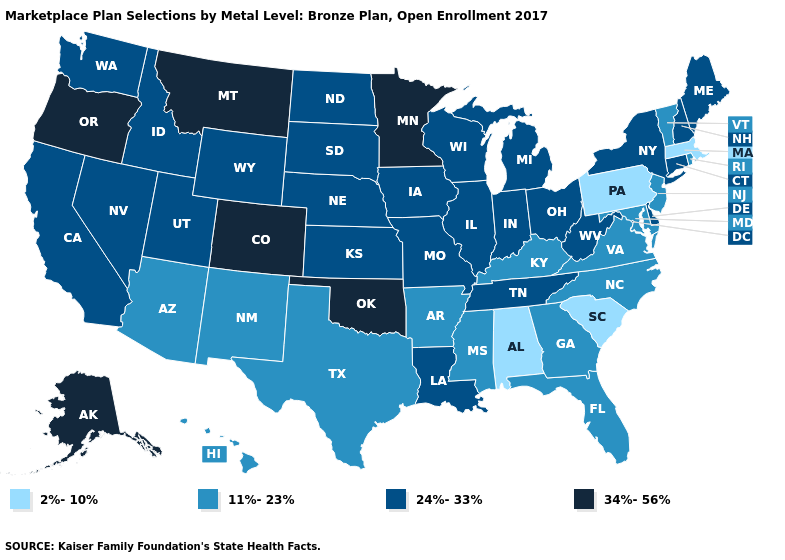Name the states that have a value in the range 24%-33%?
Quick response, please. California, Connecticut, Delaware, Idaho, Illinois, Indiana, Iowa, Kansas, Louisiana, Maine, Michigan, Missouri, Nebraska, Nevada, New Hampshire, New York, North Dakota, Ohio, South Dakota, Tennessee, Utah, Washington, West Virginia, Wisconsin, Wyoming. Name the states that have a value in the range 11%-23%?
Quick response, please. Arizona, Arkansas, Florida, Georgia, Hawaii, Kentucky, Maryland, Mississippi, New Jersey, New Mexico, North Carolina, Rhode Island, Texas, Vermont, Virginia. What is the highest value in states that border Idaho?
Give a very brief answer. 34%-56%. What is the highest value in the USA?
Concise answer only. 34%-56%. Name the states that have a value in the range 11%-23%?
Concise answer only. Arizona, Arkansas, Florida, Georgia, Hawaii, Kentucky, Maryland, Mississippi, New Jersey, New Mexico, North Carolina, Rhode Island, Texas, Vermont, Virginia. What is the highest value in the USA?
Concise answer only. 34%-56%. Does Arkansas have the lowest value in the USA?
Give a very brief answer. No. What is the lowest value in the MidWest?
Give a very brief answer. 24%-33%. Name the states that have a value in the range 11%-23%?
Short answer required. Arizona, Arkansas, Florida, Georgia, Hawaii, Kentucky, Maryland, Mississippi, New Jersey, New Mexico, North Carolina, Rhode Island, Texas, Vermont, Virginia. Name the states that have a value in the range 24%-33%?
Short answer required. California, Connecticut, Delaware, Idaho, Illinois, Indiana, Iowa, Kansas, Louisiana, Maine, Michigan, Missouri, Nebraska, Nevada, New Hampshire, New York, North Dakota, Ohio, South Dakota, Tennessee, Utah, Washington, West Virginia, Wisconsin, Wyoming. Does Vermont have a lower value than North Carolina?
Quick response, please. No. Does South Carolina have the lowest value in the USA?
Quick response, please. Yes. What is the value of Colorado?
Quick response, please. 34%-56%. Does the map have missing data?
Concise answer only. No. Is the legend a continuous bar?
Be succinct. No. 